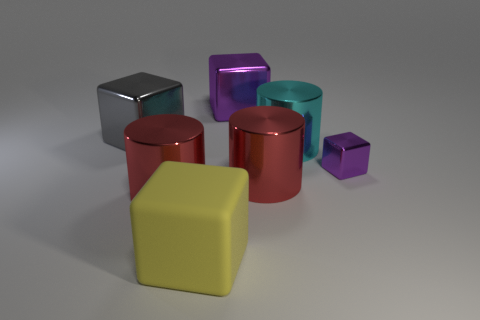Add 3 small cyan metal objects. How many objects exist? 10 Subtract all cylinders. How many objects are left? 4 Add 1 large red metallic objects. How many large red metallic objects are left? 3 Add 2 large red cylinders. How many large red cylinders exist? 4 Subtract 0 brown blocks. How many objects are left? 7 Subtract all large red metallic spheres. Subtract all tiny metal objects. How many objects are left? 6 